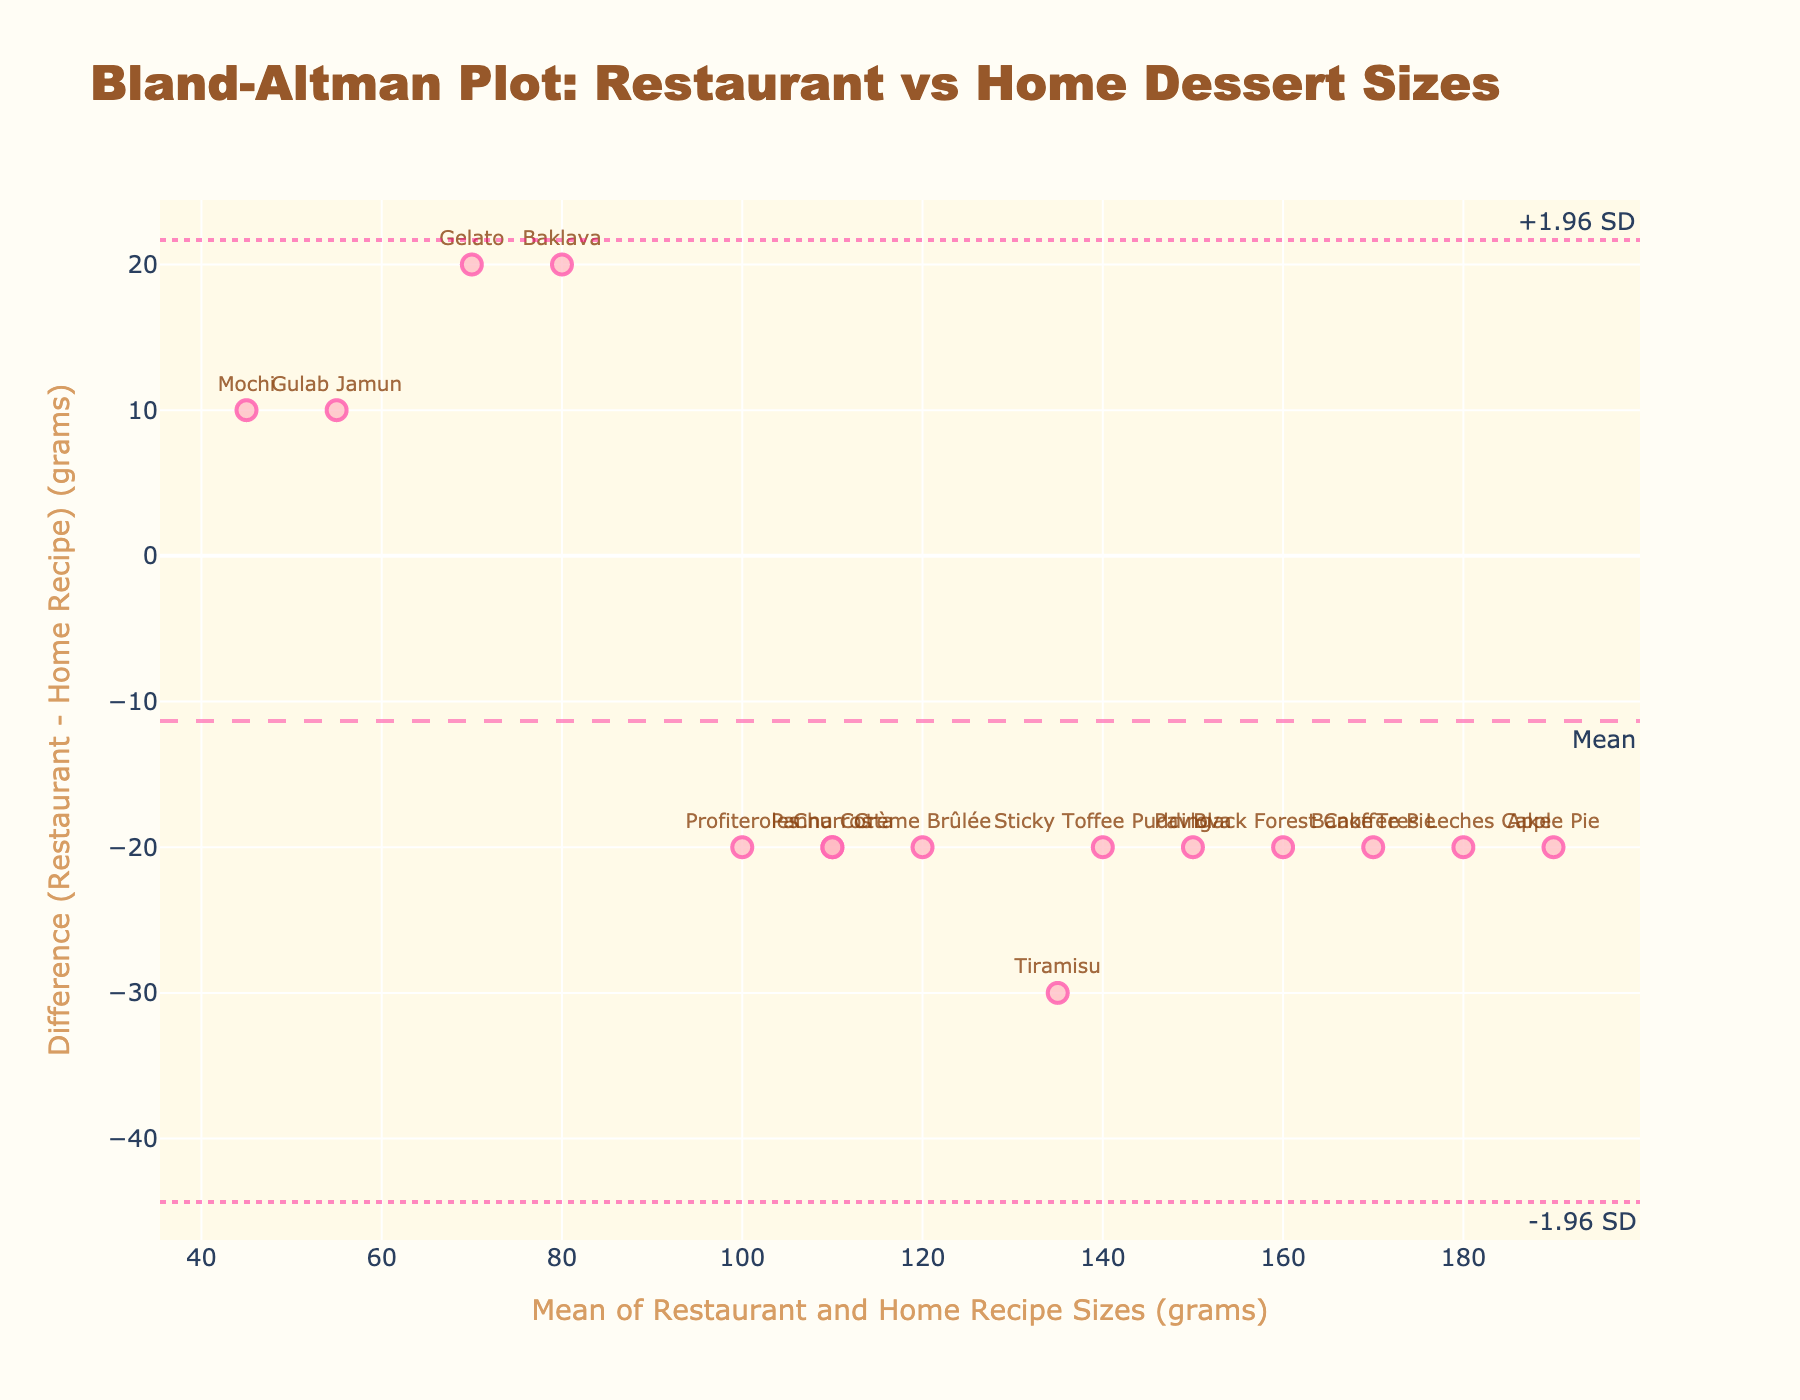What is the title of the figure? The title is often positioned at the top of the plot and provides insight into what the figure is about. In this case, it indicates that the plot is comparing dessert sizes between restaurants and home recipes.
Answer: Bland-Altman Plot: Restaurant vs Home Dessert Sizes What are the units used on the x-axis and y-axis? The axes typically have labels that specify the units of measurement. Here, the x-axis represents the mean of dessert sizes in grams, and the y-axis shows the difference in grams.
Answer: grams What is the largest positive difference shown in the plot? The y-axis indicates the difference between restaurant and home recipe sizes. The largest positive difference is approximately close to the topmost point on this axis. It's marked by a text label "Gelato."
Answer: 20 grams Which dessert has the smallest mean size? Mean size can be determined from the x-axis, which is the average of restaurant and home recipe weights. The smallest mean size can be identified by examining the leftmost point on the x-axis.
Answer: Mochi What are the limits of agreement in this plot? Limits of agreement are typically represented by horizontal dashed lines at ±1.96 standard deviations from the mean difference. These lines help understand the agreement between the two sets of measurements. They can be identified near the labels "+1.96 SD" and "-1.96 SD" on the plot.
Answer: Approximately -23.3 grams and 3.3 grams Which dessert has the largest negative difference between restaurant and home recipe sizes? The y-axis shows differences, with negative values indicating the restaurant size is smaller. The point furthest down the y-axis represents the largest negative difference, which is labeled "Baklava."
Answer: Baklava How many desserts are plotted in the figure? Each marker on the plot represents a dessert. Counting the number of markers will provide the total number of desserts displayed.
Answer: 15 What is the mean difference between restaurant and home recipe sizes? The mean difference is usually represented by a horizontal line, often with a label like "Mean." This value indicates the average difference between the two measurements. The line in the middle of the plot indicates this mean difference.
Answer: -10 grams Which dessert has the largest discrepancy in terms of portion size between restaurant and home recipe? The dessert with the largest discrepancy will be the marker furthest from the mean difference line, either positively or negatively along the y-axis. The farthest point upwards is "Gelato," and downwards is "Baklava," with Baklava having a larger discrepancy comparison to mean difference.
Answer: Baklava Which desserts have a home recipe size larger than the restaurant size? To find these desserts, look for markers positioned below the mean zero line because negative values denote restaurant sizes smaller than home recipe sizes. Various points like "Mochi," "Baklava," and "Gelato" fall below the x-axis.
Answer: Mochi, Baklava, Gelato 